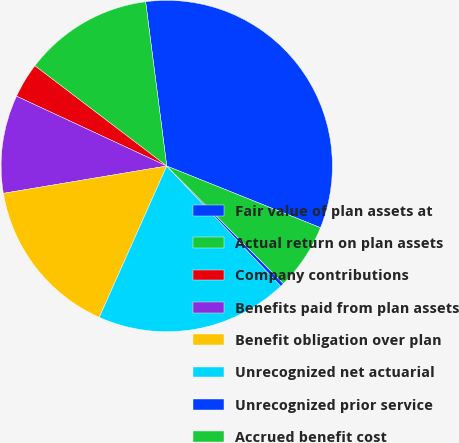<chart> <loc_0><loc_0><loc_500><loc_500><pie_chart><fcel>Fair value of plan assets at<fcel>Actual return on plan assets<fcel>Company contributions<fcel>Benefits paid from plan assets<fcel>Benefit obligation over plan<fcel>Unrecognized net actuarial<fcel>Unrecognized prior service<fcel>Accrued benefit cost<nl><fcel>33.11%<fcel>12.62%<fcel>3.42%<fcel>9.56%<fcel>15.69%<fcel>18.76%<fcel>0.35%<fcel>6.49%<nl></chart> 